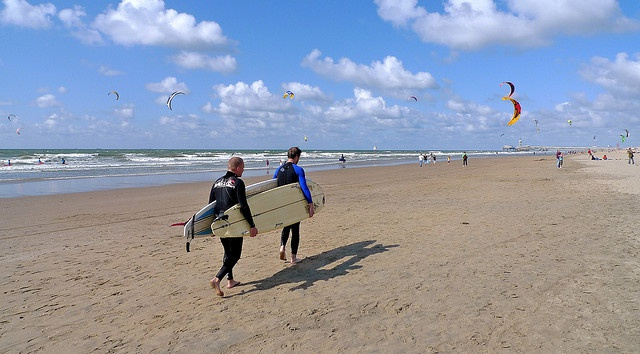Describe the objects in this image and their specific colors. I can see surfboard in lightblue, gray, and darkgray tones, people in lightblue, black, gray, and maroon tones, people in lightblue, black, darkgray, gray, and tan tones, surfboard in lightblue, gray, and black tones, and kite in lightblue, orange, maroon, brown, and olive tones in this image. 